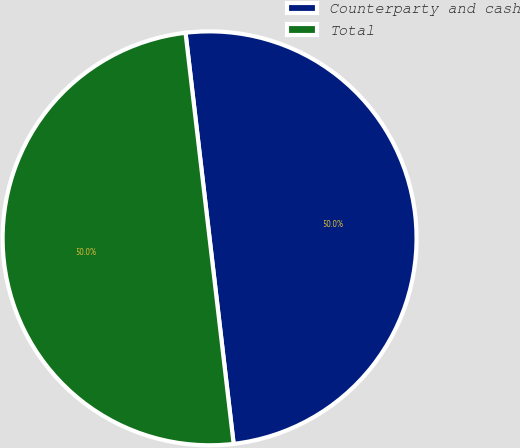Convert chart. <chart><loc_0><loc_0><loc_500><loc_500><pie_chart><fcel>Counterparty and cash<fcel>Total<nl><fcel>50.0%<fcel>50.0%<nl></chart> 